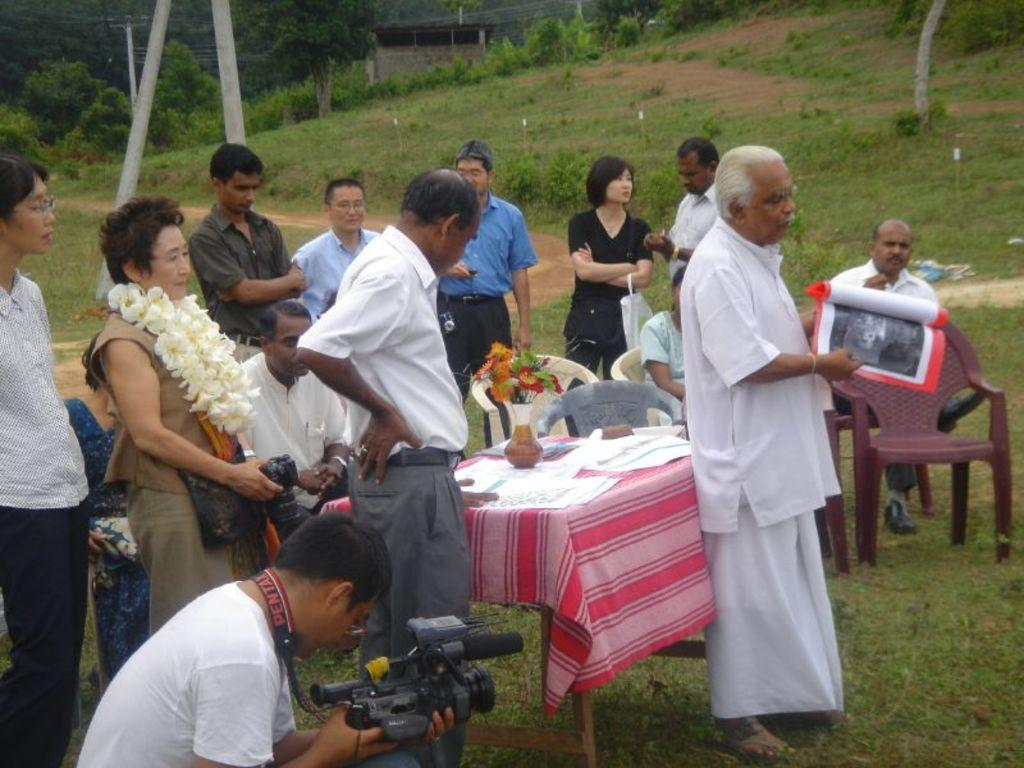How many people are in the image? There are multiple people in the image. What are the people in the image doing? The people are standing. Can you describe the man in the image? The man is using a video camera. What is the man doing with the video camera? The man is recording a video. What is the company's reaction to the video being recorded in the image? There is no company mentioned in the image, and therefore no reaction can be observed. 